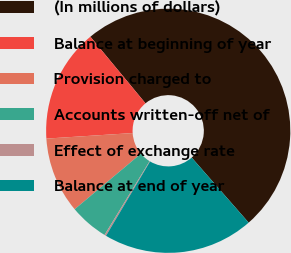Convert chart to OTSL. <chart><loc_0><loc_0><loc_500><loc_500><pie_chart><fcel>(In millions of dollars)<fcel>Balance at beginning of year<fcel>Provision charged to<fcel>Accounts written-off net of<fcel>Effect of exchange rate<fcel>Balance at end of year<nl><fcel>49.56%<fcel>15.02%<fcel>10.09%<fcel>5.16%<fcel>0.22%<fcel>19.96%<nl></chart> 